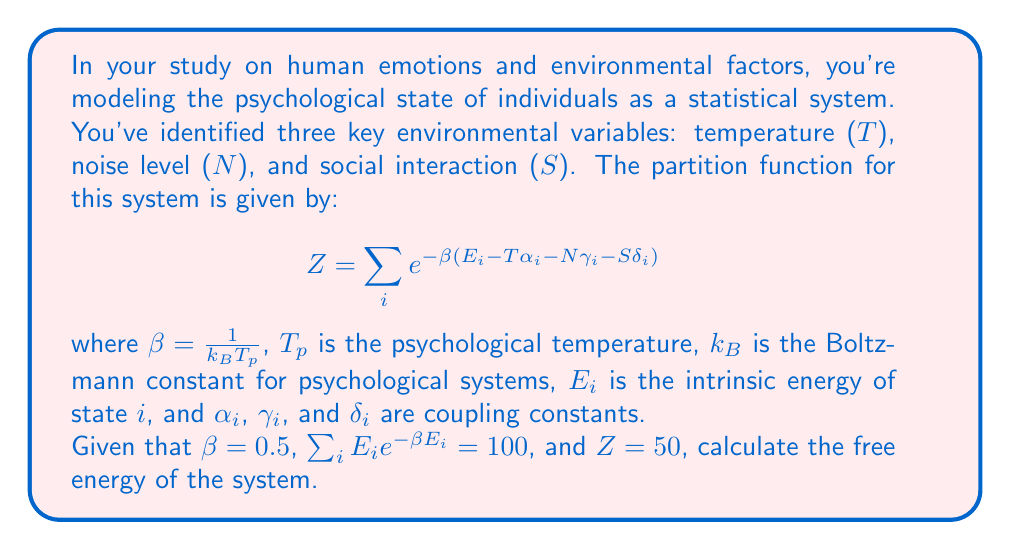Provide a solution to this math problem. To solve this problem, we'll use the fundamental relationship between the partition function and free energy in statistical mechanics. Let's proceed step-by-step:

1) The free energy F is related to the partition function Z by the equation:

   $$F = -\frac{1}{\beta} \ln Z$$

2) We're given that $\beta = 0.5$ and $Z = 50$. Let's substitute these values:

   $$F = -\frac{1}{0.5} \ln 50$$

3) Simplify:
   
   $$F = -2 \ln 50$$

4) Calculate the natural logarithm:
   
   $$F = -2 * 3.912023005 = -7.824046010$$

5) Round to three decimal places:

   $$F \approx -7.824$$

Note: The units of F would depend on the units used for the psychological temperature and the Boltzmann constant for psychological systems. These aren't specified in the problem, so we'll leave the result as a dimensionless number.
Answer: $-7.824$ 